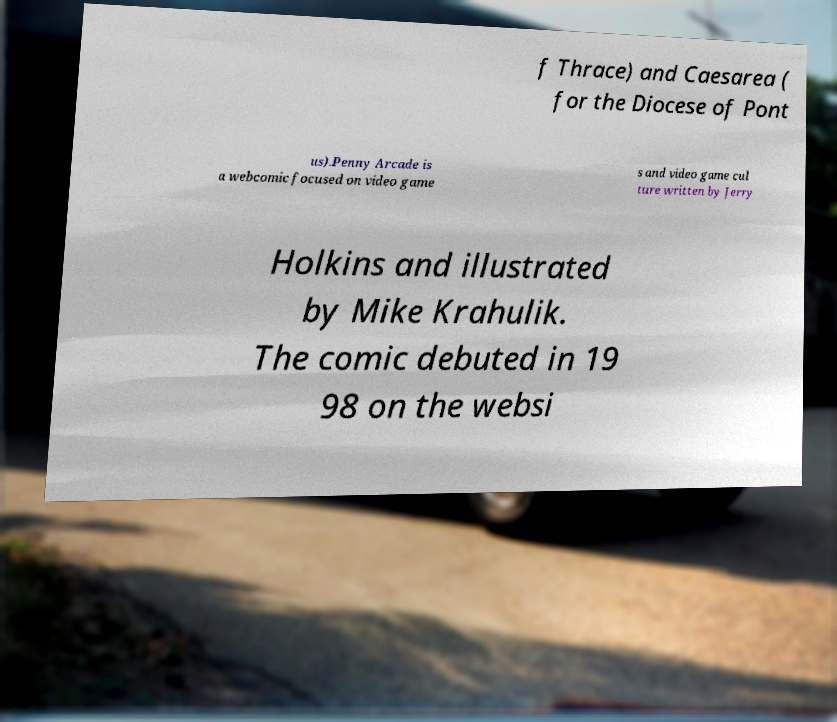For documentation purposes, I need the text within this image transcribed. Could you provide that? f Thrace) and Caesarea ( for the Diocese of Pont us).Penny Arcade is a webcomic focused on video game s and video game cul ture written by Jerry Holkins and illustrated by Mike Krahulik. The comic debuted in 19 98 on the websi 